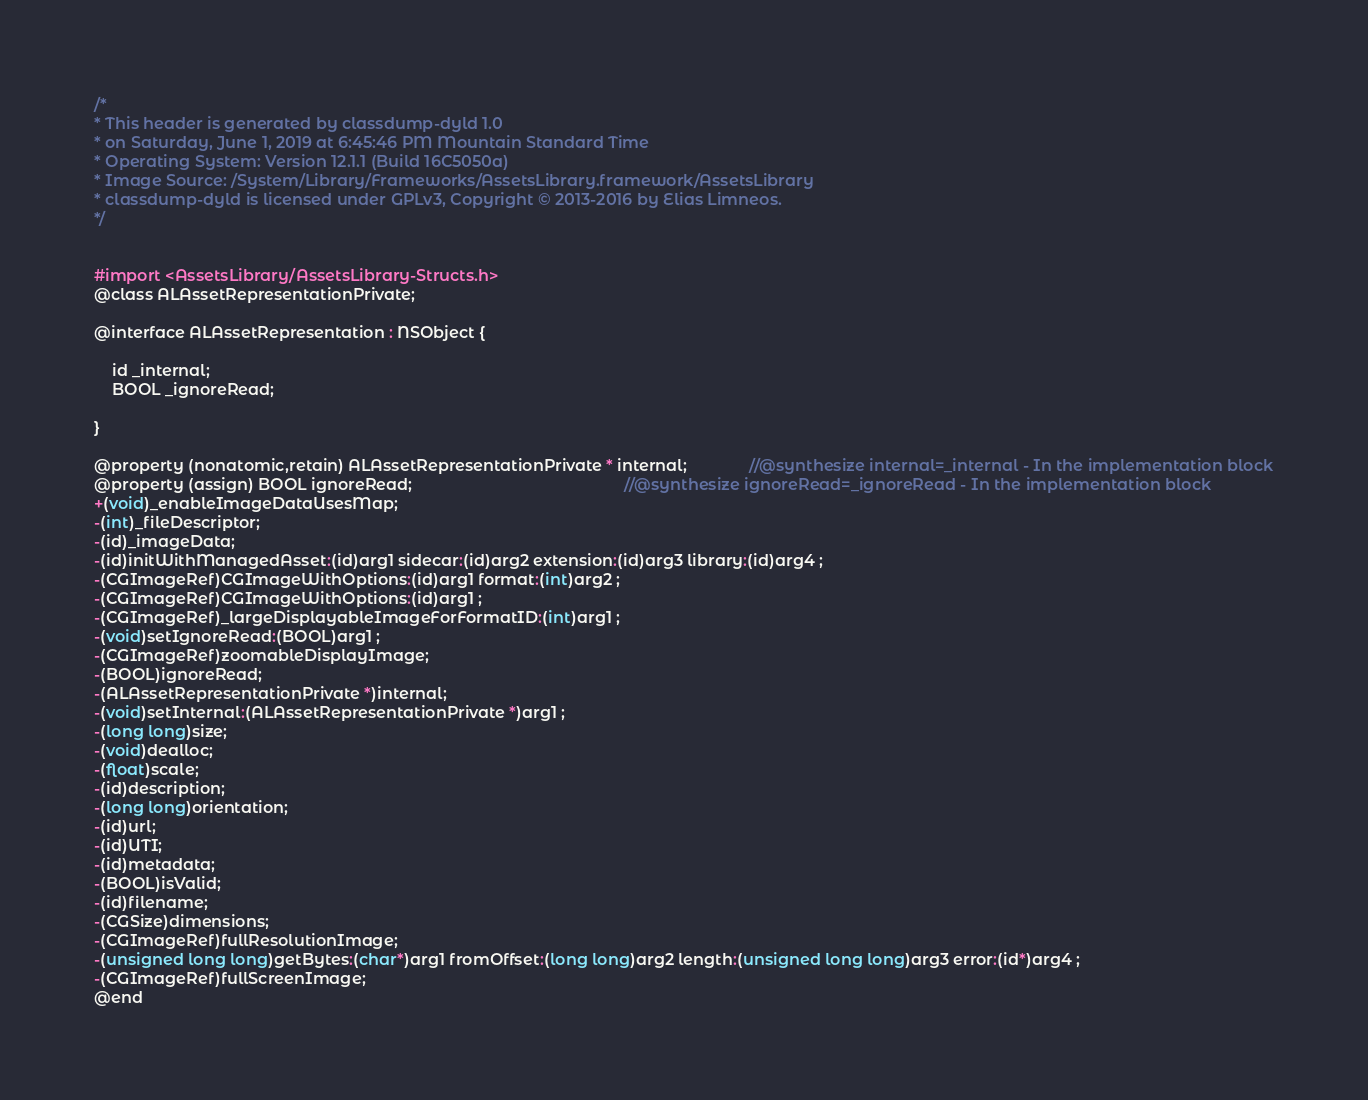<code> <loc_0><loc_0><loc_500><loc_500><_C_>/*
* This header is generated by classdump-dyld 1.0
* on Saturday, June 1, 2019 at 6:45:46 PM Mountain Standard Time
* Operating System: Version 12.1.1 (Build 16C5050a)
* Image Source: /System/Library/Frameworks/AssetsLibrary.framework/AssetsLibrary
* classdump-dyld is licensed under GPLv3, Copyright © 2013-2016 by Elias Limneos.
*/


#import <AssetsLibrary/AssetsLibrary-Structs.h>
@class ALAssetRepresentationPrivate;

@interface ALAssetRepresentation : NSObject {

	id _internal;
	BOOL _ignoreRead;

}

@property (nonatomic,retain) ALAssetRepresentationPrivate * internal;              //@synthesize internal=_internal - In the implementation block
@property (assign) BOOL ignoreRead;                                                //@synthesize ignoreRead=_ignoreRead - In the implementation block
+(void)_enableImageDataUsesMap;
-(int)_fileDescriptor;
-(id)_imageData;
-(id)initWithManagedAsset:(id)arg1 sidecar:(id)arg2 extension:(id)arg3 library:(id)arg4 ;
-(CGImageRef)CGImageWithOptions:(id)arg1 format:(int)arg2 ;
-(CGImageRef)CGImageWithOptions:(id)arg1 ;
-(CGImageRef)_largeDisplayableImageForFormatID:(int)arg1 ;
-(void)setIgnoreRead:(BOOL)arg1 ;
-(CGImageRef)zoomableDisplayImage;
-(BOOL)ignoreRead;
-(ALAssetRepresentationPrivate *)internal;
-(void)setInternal:(ALAssetRepresentationPrivate *)arg1 ;
-(long long)size;
-(void)dealloc;
-(float)scale;
-(id)description;
-(long long)orientation;
-(id)url;
-(id)UTI;
-(id)metadata;
-(BOOL)isValid;
-(id)filename;
-(CGSize)dimensions;
-(CGImageRef)fullResolutionImage;
-(unsigned long long)getBytes:(char*)arg1 fromOffset:(long long)arg2 length:(unsigned long long)arg3 error:(id*)arg4 ;
-(CGImageRef)fullScreenImage;
@end

</code> 